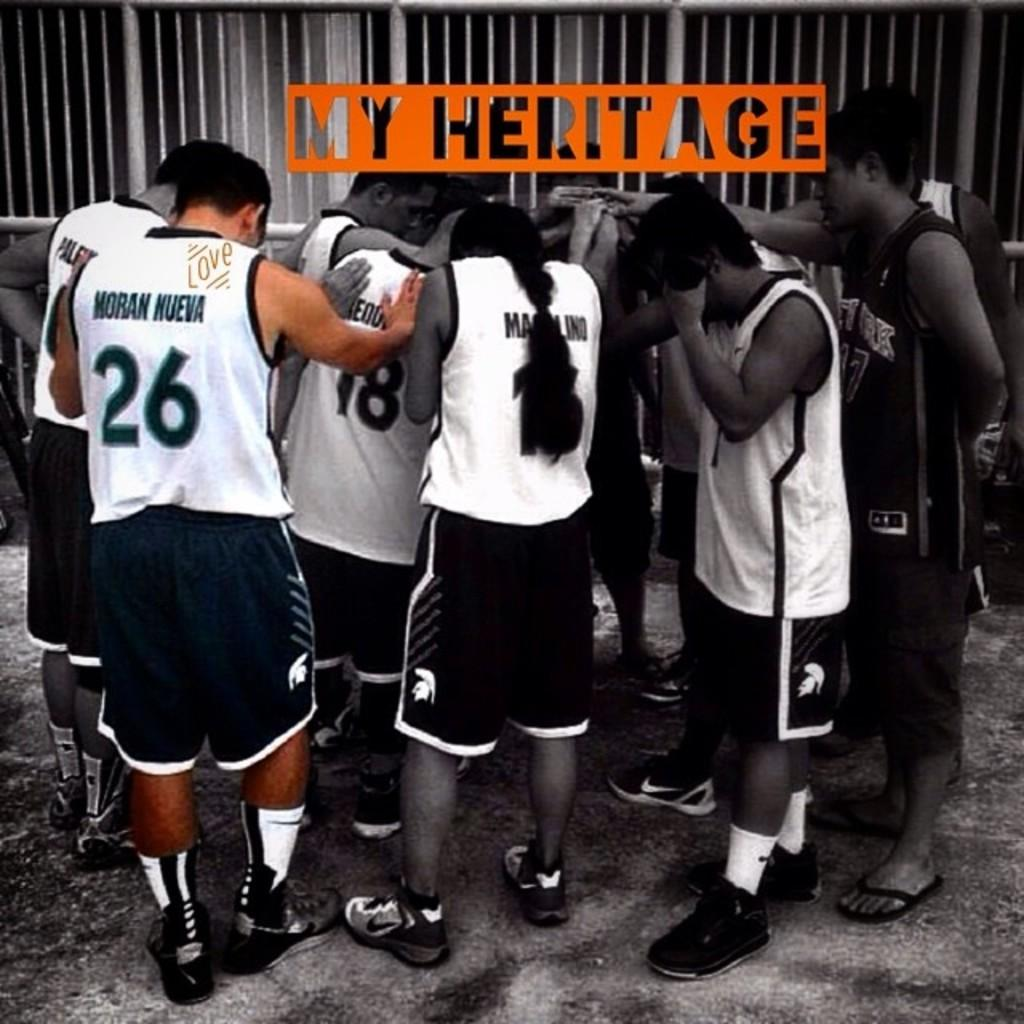Provide a one-sentence caption for the provided image. the picture labeled My Heritage showing a group of athletes standing in a circle. 